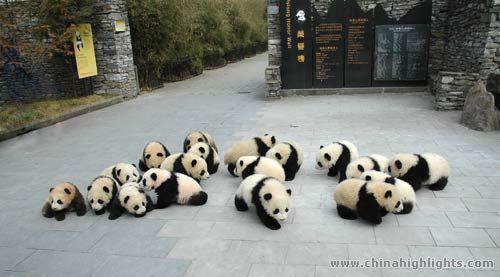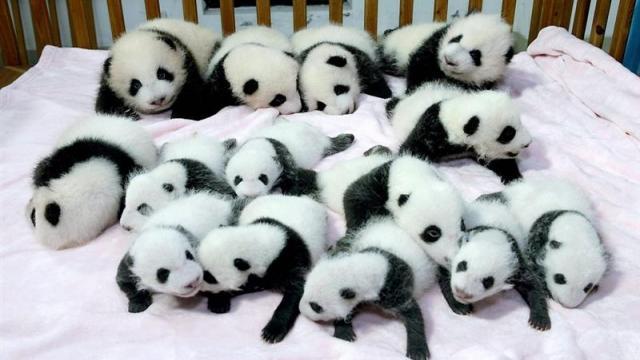The first image is the image on the left, the second image is the image on the right. Considering the images on both sides, is "Exactly two pandas are playing in the snow in one of the images." valid? Answer yes or no. No. The first image is the image on the left, the second image is the image on the right. Analyze the images presented: Is the assertion "At least one image shows many pandas on a white blanket surrounded by wooden rails, like a crib." valid? Answer yes or no. Yes. 